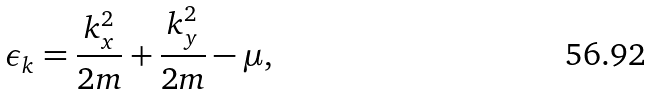Convert formula to latex. <formula><loc_0><loc_0><loc_500><loc_500>\epsilon _ { k } = \frac { k _ { x } ^ { 2 } } { 2 m } + \frac { k _ { y } ^ { 2 } } { 2 m } - \mu ,</formula> 